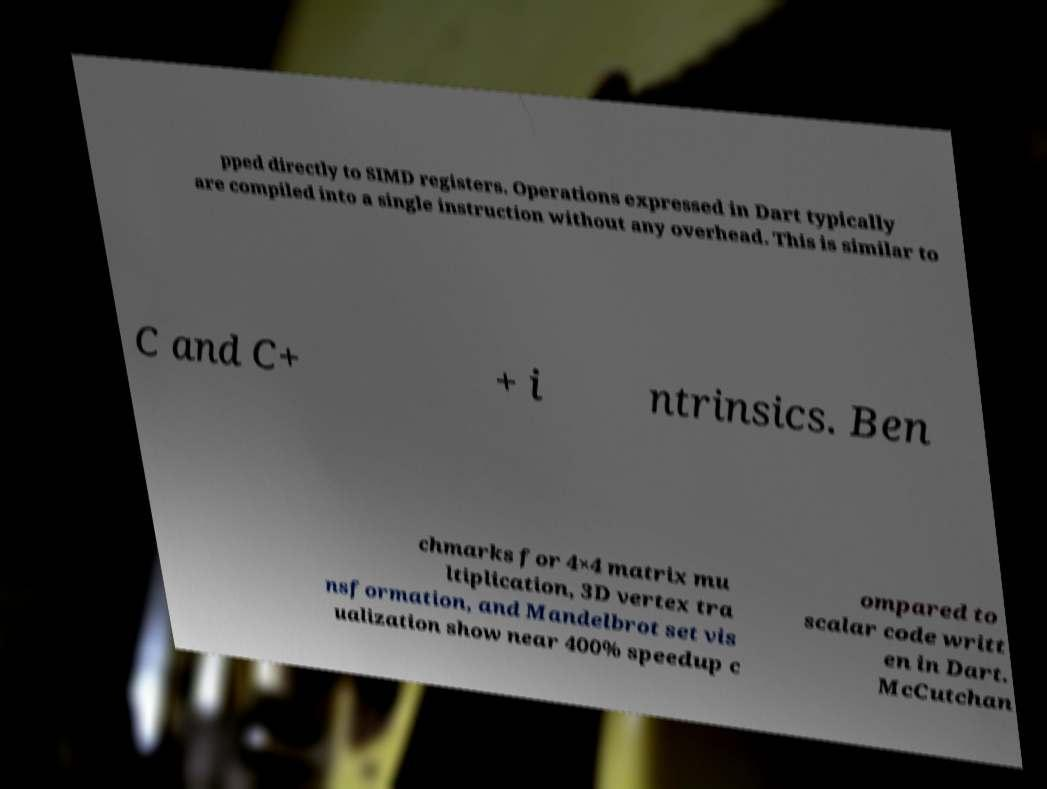Please identify and transcribe the text found in this image. pped directly to SIMD registers. Operations expressed in Dart typically are compiled into a single instruction without any overhead. This is similar to C and C+ + i ntrinsics. Ben chmarks for 4×4 matrix mu ltiplication, 3D vertex tra nsformation, and Mandelbrot set vis ualization show near 400% speedup c ompared to scalar code writt en in Dart. McCutchan 